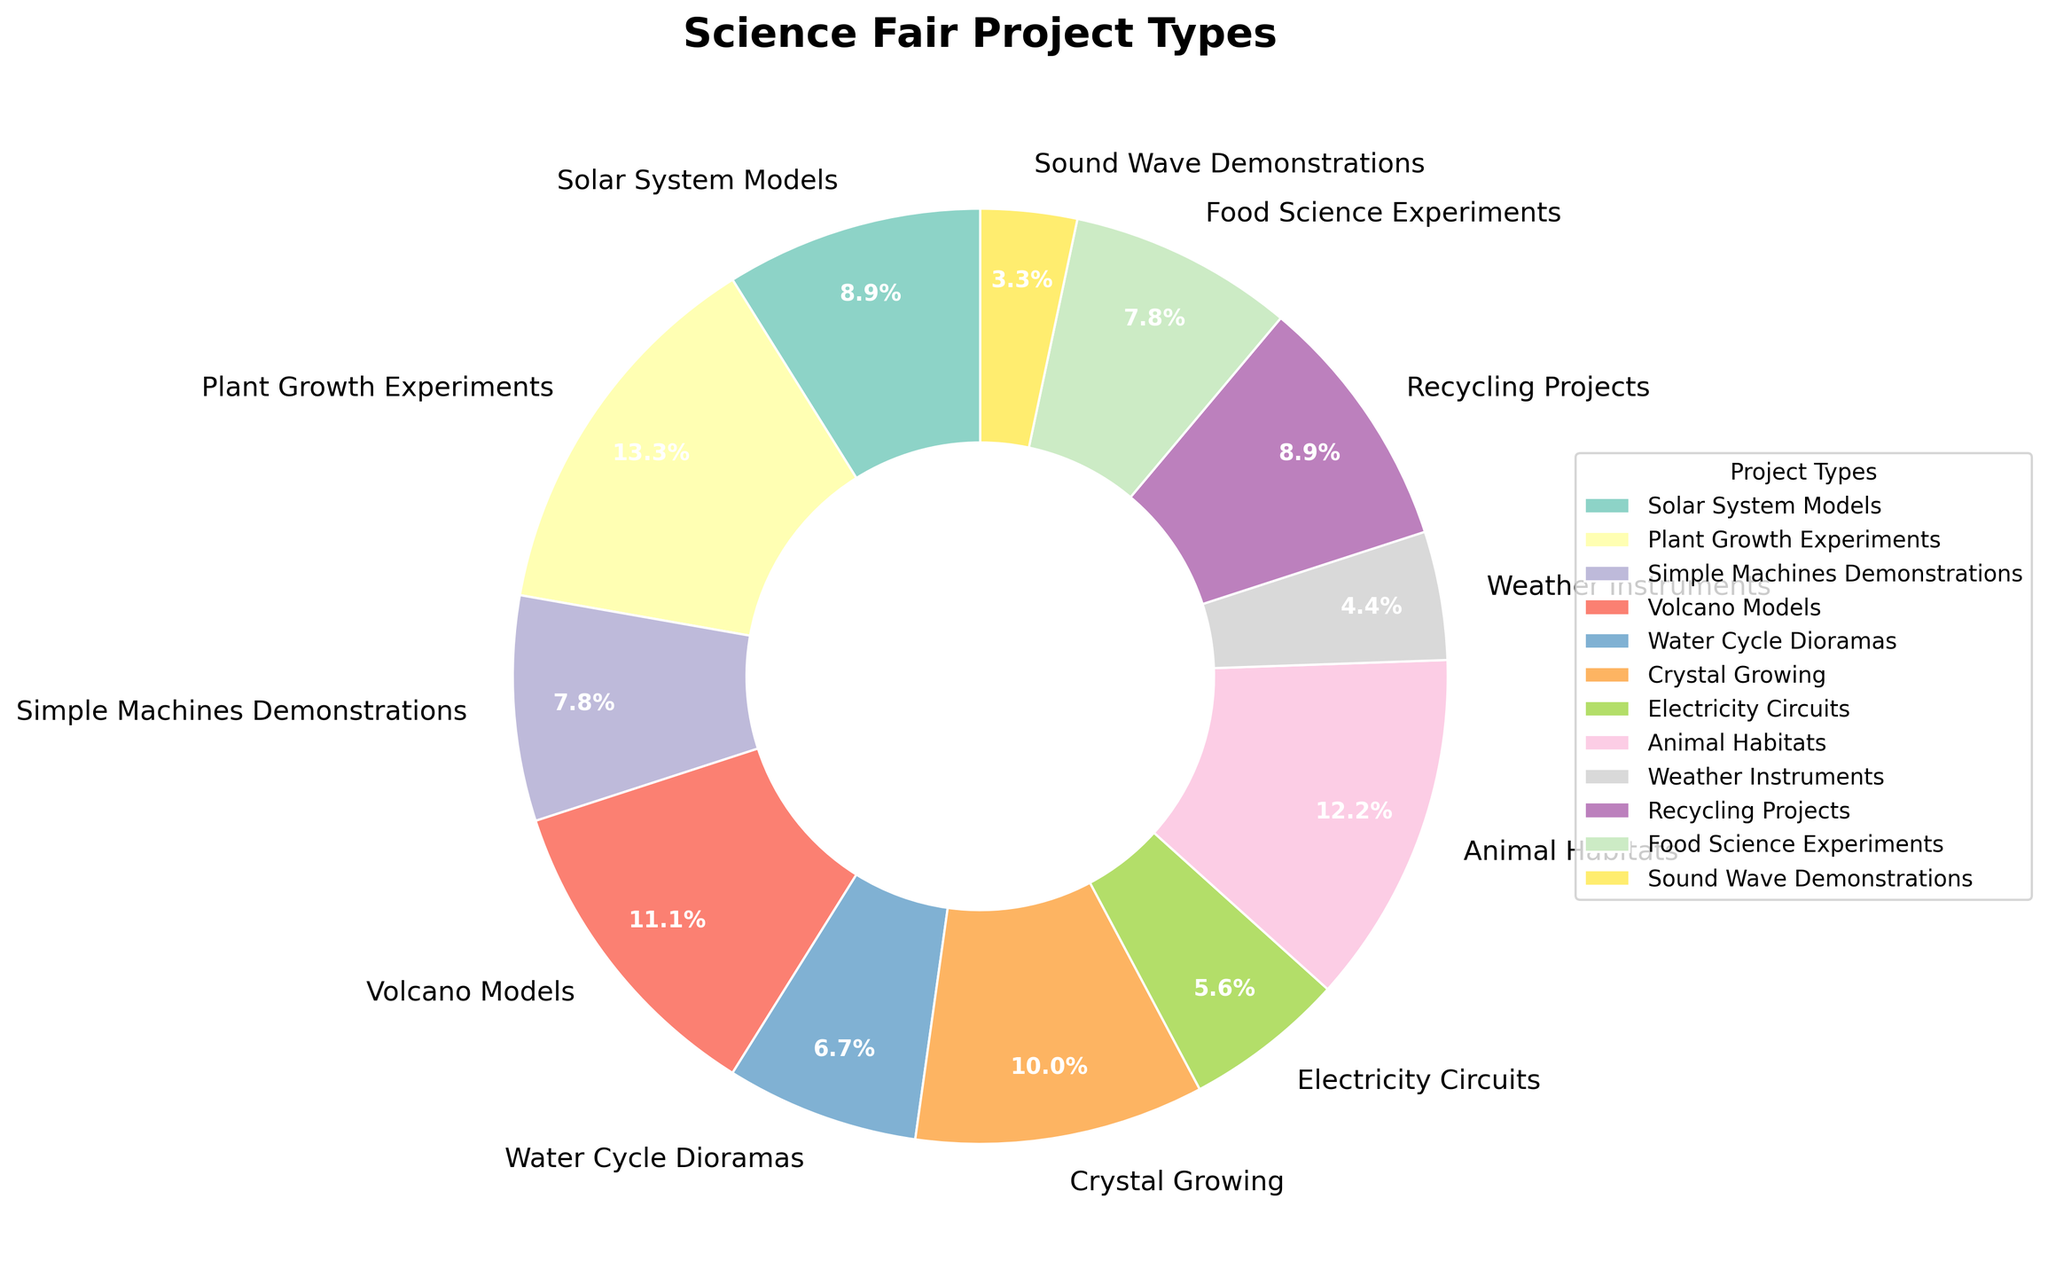Which project type has the highest number of students? First, locate the project type with the largest slice in the pie. The project with the highest number of students is the one with the largest percentage shown in the center.
Answer: Plant Growth Experiments Which project type has the smallest number of students? Identify the smallest slice in the pie chart. The project with the smallest number of students is the one with the smallest percentage shown in the center.
Answer: Sound Wave Demonstrations Which two project types have the same number of students? Observe the pie chart to find two slices that are equal in size. These will have identical percentages shown in the center.
Answer: Solar System Models and Recycling Projects What is the total number of students that chose either Volcano Models or Crystal Growing? Add the number of students who chose Volcano Models (10) and those who chose Crystal Growing (9). Therefore, 10 + 9 = 19 students chose either of these projects.
Answer: 19 How many more students chose Plant Growth Experiments compared to Weather Instruments? Subtract the number of students who chose Weather Instruments (4) from those who chose Plant Growth Experiments (12). So, 12 - 4 = 8 students.
Answer: 8 What percentage of students chose either Animal Habitats or Food Science Experiments? Add the percentages of students who chose Animal Habitats and Food Science Experiments. Animal Habitats is 11 students out of 90 total students (11/90) which is approximately 12.2%. Food Science Experiments is 7 students out of 90 (7/90) which is about 7.8%. Summing these gives roughly 20%.
Answer: 20% Rank the top three most popular science fair projects. Identify the three slices with the largest percentages. The top three are Plant Growth Experiments, Animal Habitats, and Volcano Models, in that order.
Answer: Plant Growth Experiments, Animal Habitats, Volcano Models How many students participated in the science fair in total? Sum up the number of students for all project types. This is 8 + 12 + 7 + 10 + 6 + 9 + 5 + 11 + 4 + 8 + 7 + 3 = 90.
Answer: 90 